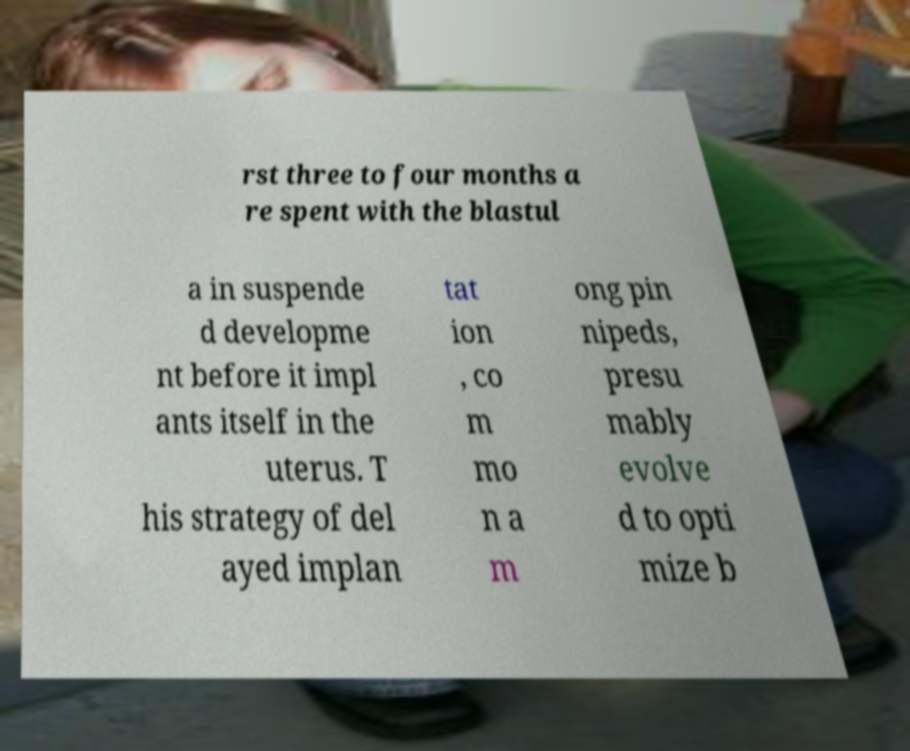For documentation purposes, I need the text within this image transcribed. Could you provide that? rst three to four months a re spent with the blastul a in suspende d developme nt before it impl ants itself in the uterus. T his strategy of del ayed implan tat ion , co m mo n a m ong pin nipeds, presu mably evolve d to opti mize b 